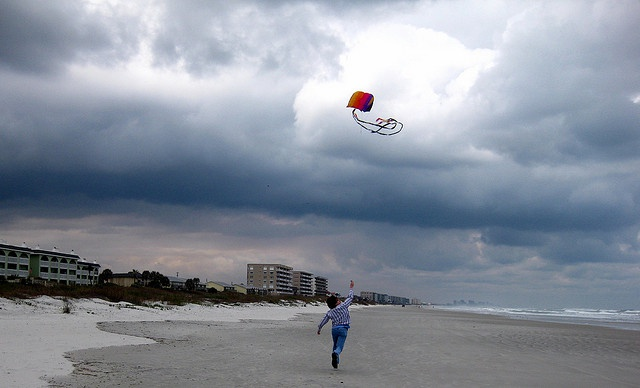Describe the objects in this image and their specific colors. I can see people in gray, black, and navy tones and kite in gray, lightgray, brown, and black tones in this image. 